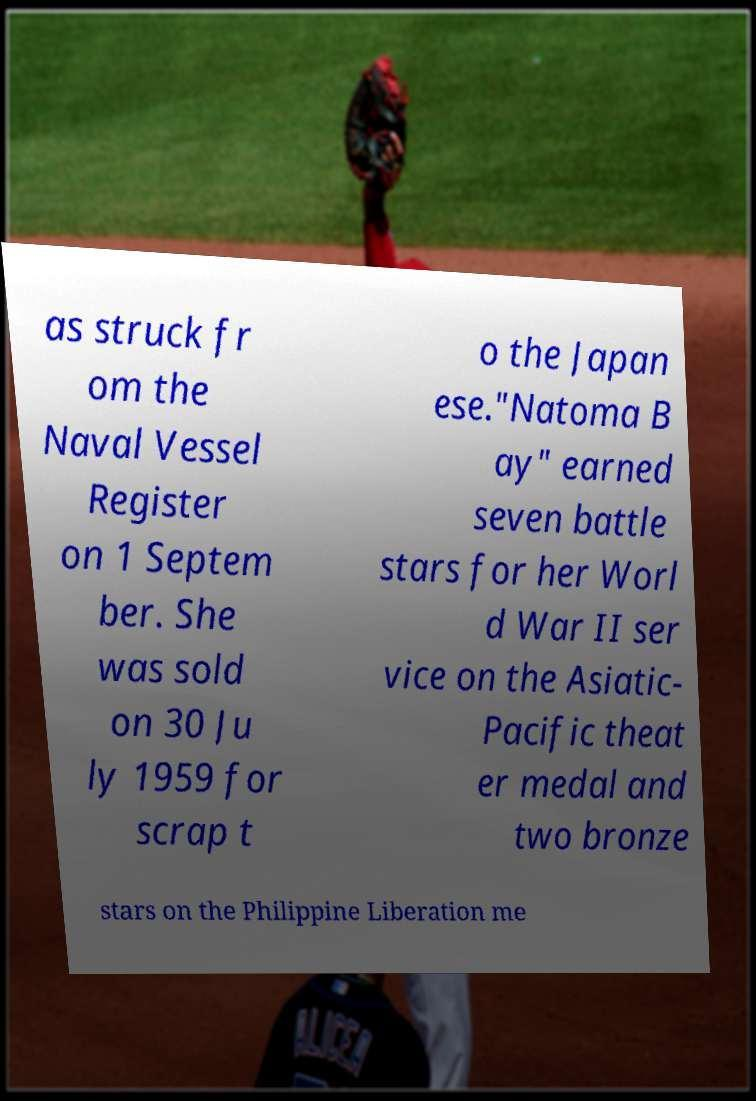I need the written content from this picture converted into text. Can you do that? as struck fr om the Naval Vessel Register on 1 Septem ber. She was sold on 30 Ju ly 1959 for scrap t o the Japan ese."Natoma B ay" earned seven battle stars for her Worl d War II ser vice on the Asiatic- Pacific theat er medal and two bronze stars on the Philippine Liberation me 